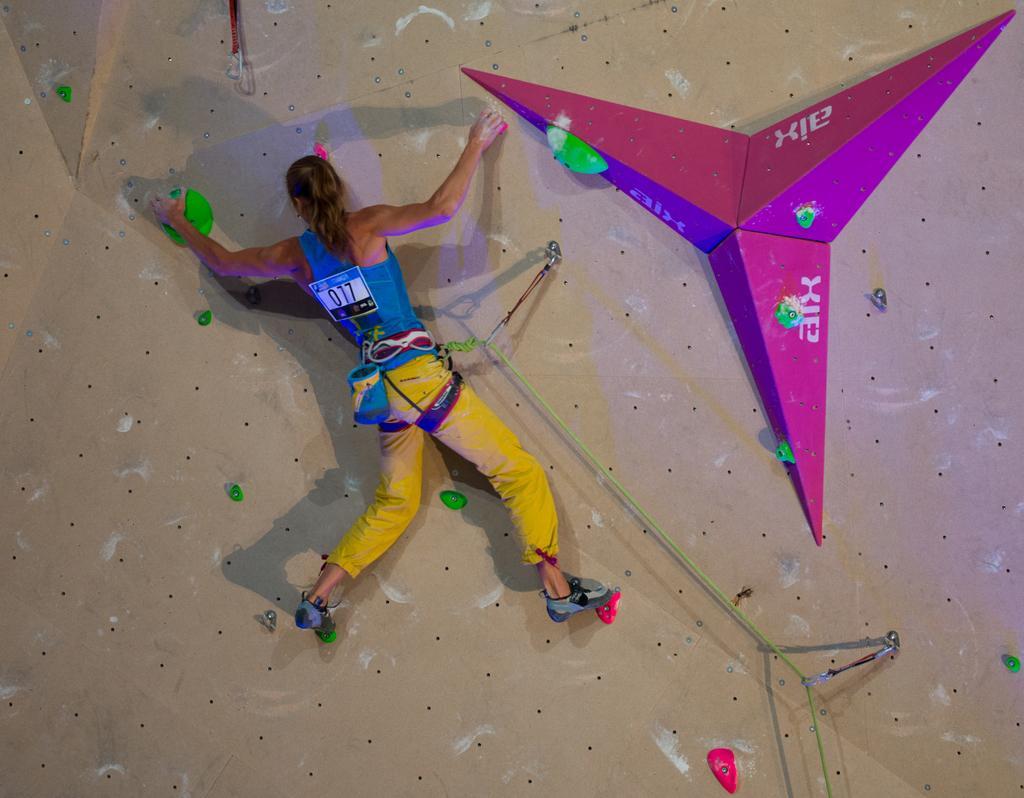How would you summarize this image in a sentence or two? In this image I can see a person wearing blue and yellow colored dress is holding green and red colored object which are attached to the wall. I can see a pink colored object is attached to the wall and a green colored rope is tied to the person. I can see the climbing wall which is brown in color and few objects attached to the wall. 